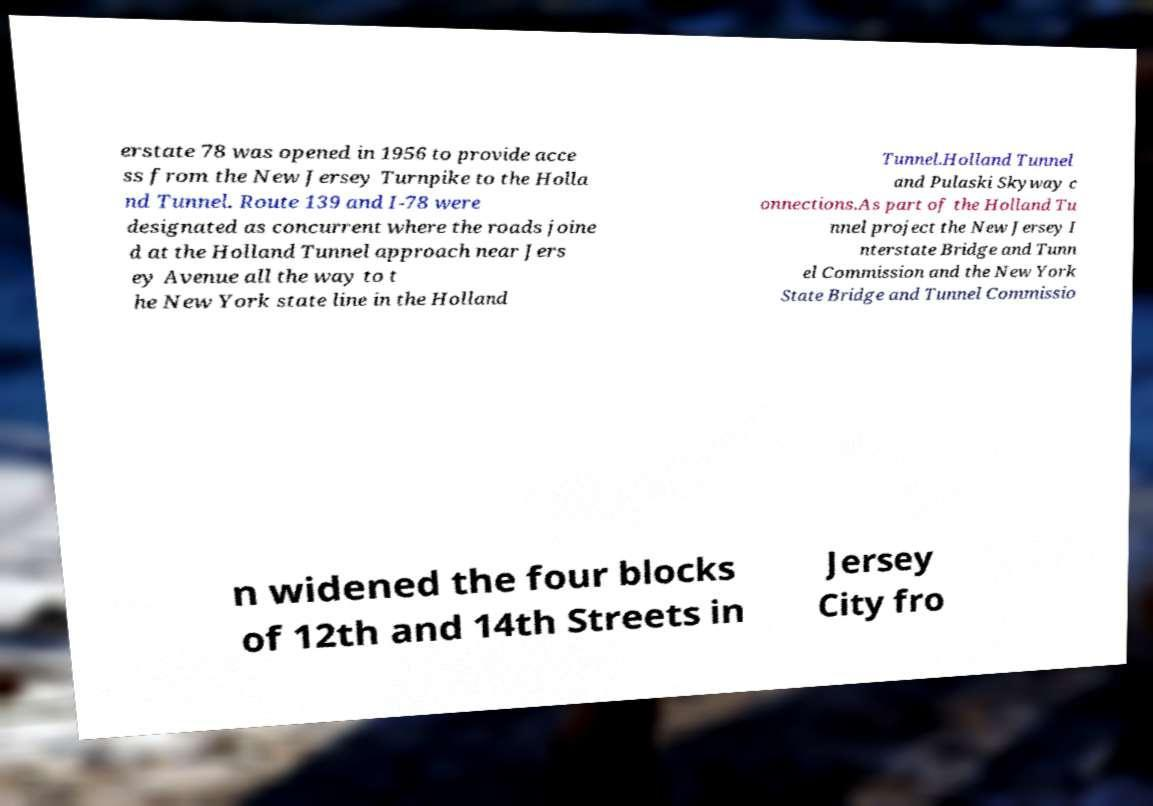Could you assist in decoding the text presented in this image and type it out clearly? erstate 78 was opened in 1956 to provide acce ss from the New Jersey Turnpike to the Holla nd Tunnel. Route 139 and I-78 were designated as concurrent where the roads joine d at the Holland Tunnel approach near Jers ey Avenue all the way to t he New York state line in the Holland Tunnel.Holland Tunnel and Pulaski Skyway c onnections.As part of the Holland Tu nnel project the New Jersey I nterstate Bridge and Tunn el Commission and the New York State Bridge and Tunnel Commissio n widened the four blocks of 12th and 14th Streets in Jersey City fro 